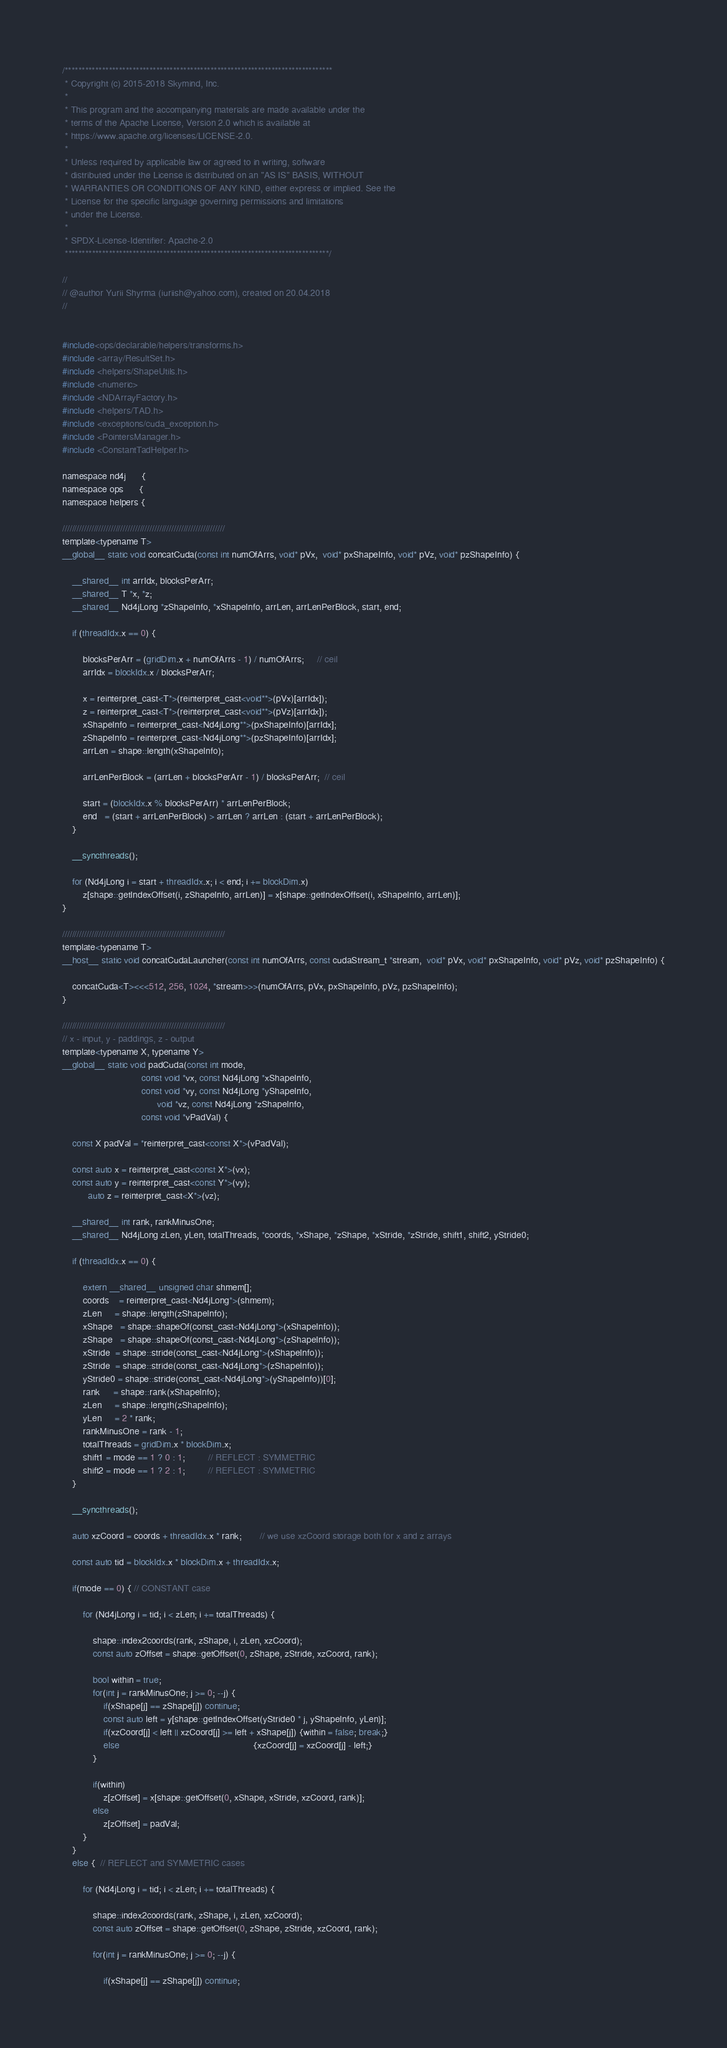Convert code to text. <code><loc_0><loc_0><loc_500><loc_500><_Cuda_>/*******************************************************************************
 * Copyright (c) 2015-2018 Skymind, Inc.
 *
 * This program and the accompanying materials are made available under the
 * terms of the Apache License, Version 2.0 which is available at
 * https://www.apache.org/licenses/LICENSE-2.0.
 *
 * Unless required by applicable law or agreed to in writing, software
 * distributed under the License is distributed on an "AS IS" BASIS, WITHOUT
 * WARRANTIES OR CONDITIONS OF ANY KIND, either express or implied. See the
 * License for the specific language governing permissions and limitations
 * under the License.
 *
 * SPDX-License-Identifier: Apache-2.0
 ******************************************************************************/

//
// @author Yurii Shyrma (iuriish@yahoo.com), created on 20.04.2018
//


#include<ops/declarable/helpers/transforms.h>
#include <array/ResultSet.h>
#include <helpers/ShapeUtils.h>
#include <numeric>
#include <NDArrayFactory.h>
#include <helpers/TAD.h>
#include <exceptions/cuda_exception.h>
#include <PointersManager.h>
#include <ConstantTadHelper.h>

namespace nd4j 	  {
namespace ops 	  {
namespace helpers {

///////////////////////////////////////////////////////////////////
template<typename T>
__global__ static void concatCuda(const int numOfArrs, void* pVx,  void* pxShapeInfo, void* pVz, void* pzShapeInfo) {

    __shared__ int arrIdx, blocksPerArr;
    __shared__ T *x, *z;
    __shared__ Nd4jLong *zShapeInfo, *xShapeInfo, arrLen, arrLenPerBlock, start, end;

    if (threadIdx.x == 0) {

        blocksPerArr = (gridDim.x + numOfArrs - 1) / numOfArrs;     // ceil
        arrIdx = blockIdx.x / blocksPerArr;

        x = reinterpret_cast<T*>(reinterpret_cast<void**>(pVx)[arrIdx]);
        z = reinterpret_cast<T*>(reinterpret_cast<void**>(pVz)[arrIdx]);
        xShapeInfo = reinterpret_cast<Nd4jLong**>(pxShapeInfo)[arrIdx];
        zShapeInfo = reinterpret_cast<Nd4jLong**>(pzShapeInfo)[arrIdx];
        arrLen = shape::length(xShapeInfo);

        arrLenPerBlock = (arrLen + blocksPerArr - 1) / blocksPerArr;  // ceil

        start = (blockIdx.x % blocksPerArr) * arrLenPerBlock;
        end   = (start + arrLenPerBlock) > arrLen ? arrLen : (start + arrLenPerBlock);
    }

    __syncthreads();

    for (Nd4jLong i = start + threadIdx.x; i < end; i += blockDim.x)
        z[shape::getIndexOffset(i, zShapeInfo, arrLen)] = x[shape::getIndexOffset(i, xShapeInfo, arrLen)];
}

///////////////////////////////////////////////////////////////////
template<typename T>
__host__ static void concatCudaLauncher(const int numOfArrs, const cudaStream_t *stream,  void* pVx, void* pxShapeInfo, void* pVz, void* pzShapeInfo) {

    concatCuda<T><<<512, 256, 1024, *stream>>>(numOfArrs, pVx, pxShapeInfo, pVz, pzShapeInfo);
}

///////////////////////////////////////////////////////////////////
// x - input, y - paddings, z - output
template<typename X, typename Y>
__global__ static void padCuda(const int mode,
                               const void *vx, const Nd4jLong *xShapeInfo,
                               const void *vy, const Nd4jLong *yShapeInfo,
                                     void *vz, const Nd4jLong *zShapeInfo,
                               const void *vPadVal) {

    const X padVal = *reinterpret_cast<const X*>(vPadVal);

    const auto x = reinterpret_cast<const X*>(vx);
    const auto y = reinterpret_cast<const Y*>(vy);
          auto z = reinterpret_cast<X*>(vz);

    __shared__ int rank, rankMinusOne;
    __shared__ Nd4jLong zLen, yLen, totalThreads, *coords, *xShape, *zShape, *xStride, *zStride, shift1, shift2, yStride0;

    if (threadIdx.x == 0) {

        extern __shared__ unsigned char shmem[];
        coords    = reinterpret_cast<Nd4jLong*>(shmem);
        zLen     = shape::length(zShapeInfo);
        xShape   = shape::shapeOf(const_cast<Nd4jLong*>(xShapeInfo));
        zShape   = shape::shapeOf(const_cast<Nd4jLong*>(zShapeInfo));
        xStride  = shape::stride(const_cast<Nd4jLong*>(xShapeInfo));
        zStride  = shape::stride(const_cast<Nd4jLong*>(zShapeInfo));
        yStride0 = shape::stride(const_cast<Nd4jLong*>(yShapeInfo))[0];
        rank     = shape::rank(xShapeInfo);
        zLen     = shape::length(zShapeInfo);
        yLen     = 2 * rank;
        rankMinusOne = rank - 1;
        totalThreads = gridDim.x * blockDim.x;
        shift1 = mode == 1 ? 0 : 1;         // REFLECT : SYMMETRIC
        shift2 = mode == 1 ? 2 : 1;         // REFLECT : SYMMETRIC
    }

    __syncthreads();

    auto xzCoord = coords + threadIdx.x * rank;       // we use xzCoord storage both for x and z arrays

    const auto tid = blockIdx.x * blockDim.x + threadIdx.x;

    if(mode == 0) { // CONSTANT case

        for (Nd4jLong i = tid; i < zLen; i += totalThreads) {

            shape::index2coords(rank, zShape, i, zLen, xzCoord);
            const auto zOffset = shape::getOffset(0, zShape, zStride, xzCoord, rank);

            bool within = true;
            for(int j = rankMinusOne; j >= 0; --j) {
                if(xShape[j] == zShape[j]) continue;
                const auto left = y[shape::getIndexOffset(yStride0 * j, yShapeInfo, yLen)];
                if(xzCoord[j] < left || xzCoord[j] >= left + xShape[j]) {within = false; break;}
                else                                                    {xzCoord[j] = xzCoord[j] - left;}
            }

            if(within)
                z[zOffset] = x[shape::getOffset(0, xShape, xStride, xzCoord, rank)];
            else
                z[zOffset] = padVal;
        }
    }
    else {  // REFLECT and SYMMETRIC cases

        for (Nd4jLong i = tid; i < zLen; i += totalThreads) {

            shape::index2coords(rank, zShape, i, zLen, xzCoord);
            const auto zOffset = shape::getOffset(0, zShape, zStride, xzCoord, rank);

            for(int j = rankMinusOne; j >= 0; --j) {

                if(xShape[j] == zShape[j]) continue;</code> 